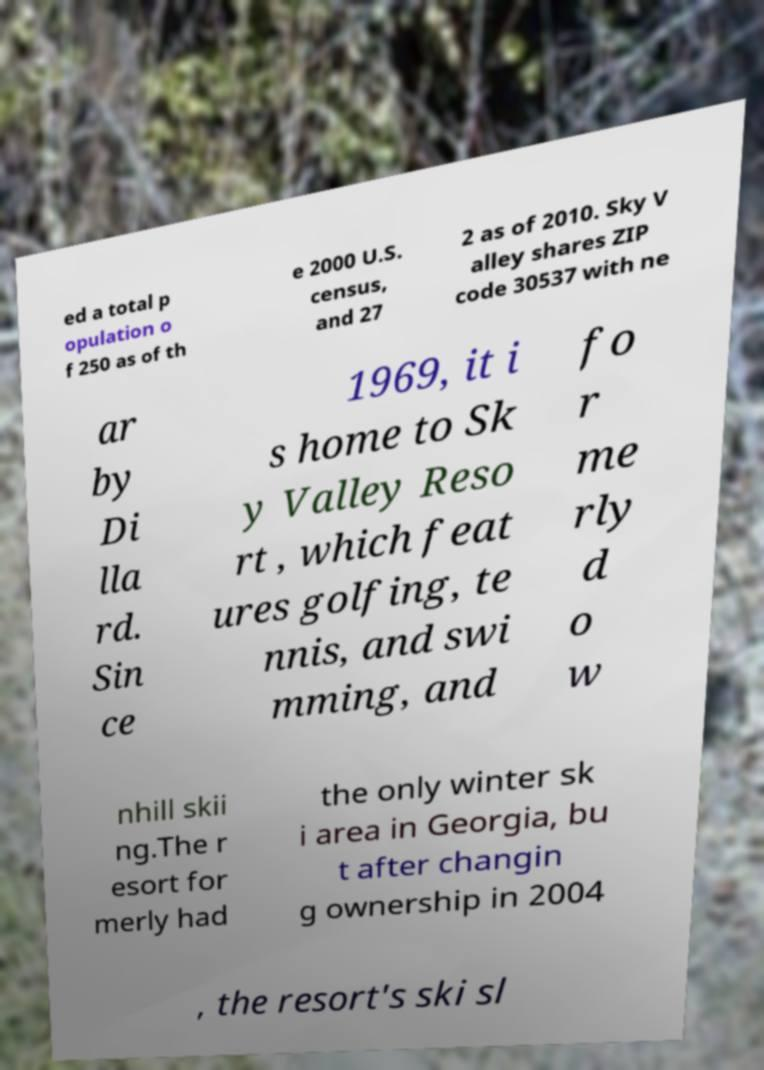I need the written content from this picture converted into text. Can you do that? ed a total p opulation o f 250 as of th e 2000 U.S. census, and 27 2 as of 2010. Sky V alley shares ZIP code 30537 with ne ar by Di lla rd. Sin ce 1969, it i s home to Sk y Valley Reso rt , which feat ures golfing, te nnis, and swi mming, and fo r me rly d o w nhill skii ng.The r esort for merly had the only winter sk i area in Georgia, bu t after changin g ownership in 2004 , the resort's ski sl 